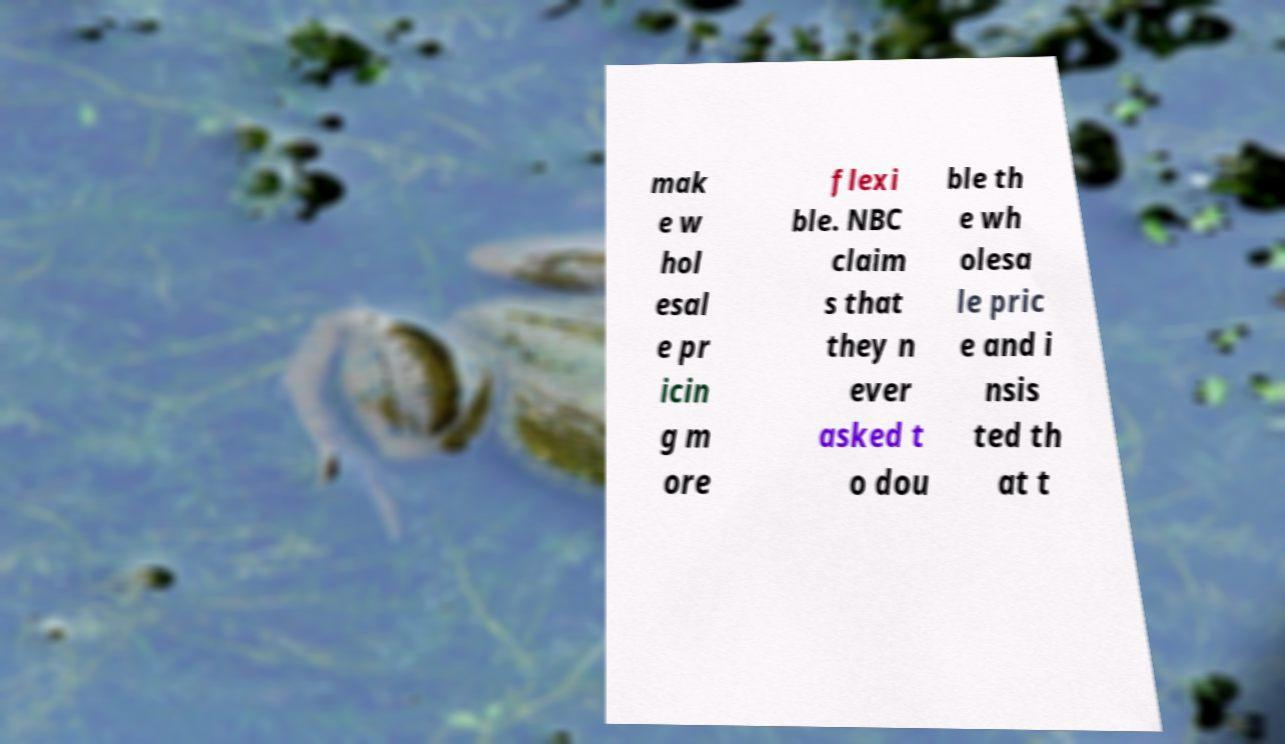What messages or text are displayed in this image? I need them in a readable, typed format. mak e w hol esal e pr icin g m ore flexi ble. NBC claim s that they n ever asked t o dou ble th e wh olesa le pric e and i nsis ted th at t 